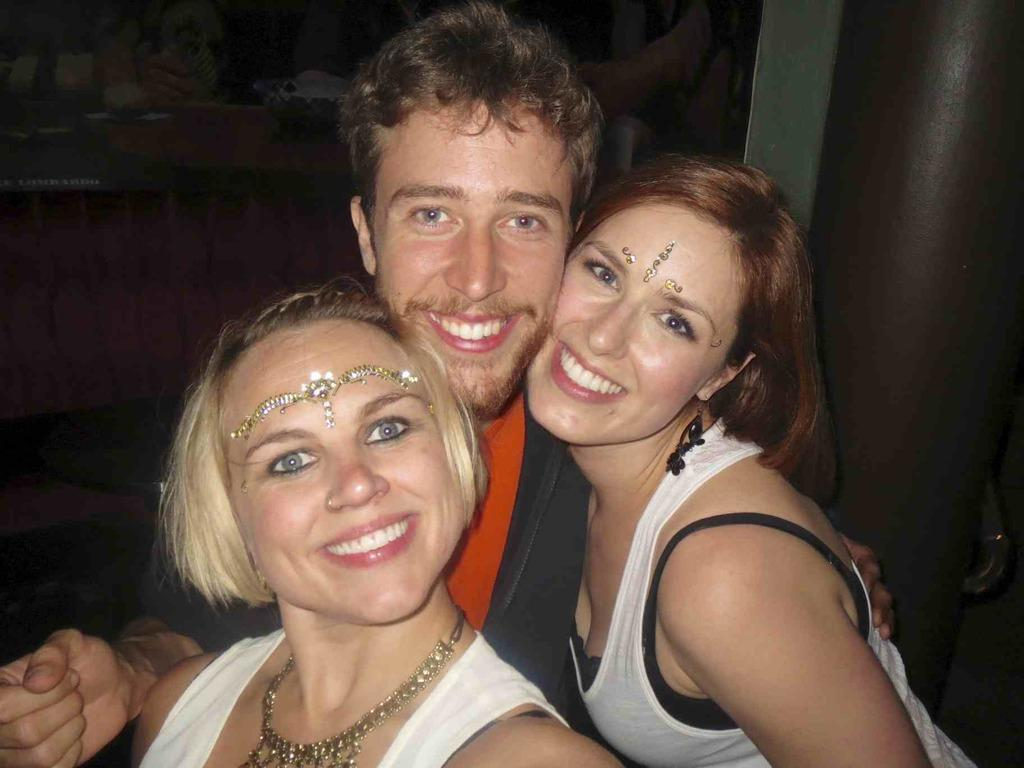How many people are in the image? There are two women and a man in the image. What are the individuals wearing? The individuals are wearing clothes. Can you describe any accessories worn by the individuals? A neck chain is visible on one of the individuals, and earrings are present on one of the individuals. What is a unique feature visible on one of the individuals? A forehead sticker is visible on one of the individuals. What is the general expression of the individuals in the image? The three individuals are smiling. What type of brick is used to construct the wall behind the individuals in the image? There is no wall or brick visible in the image; it only features the three individuals. 